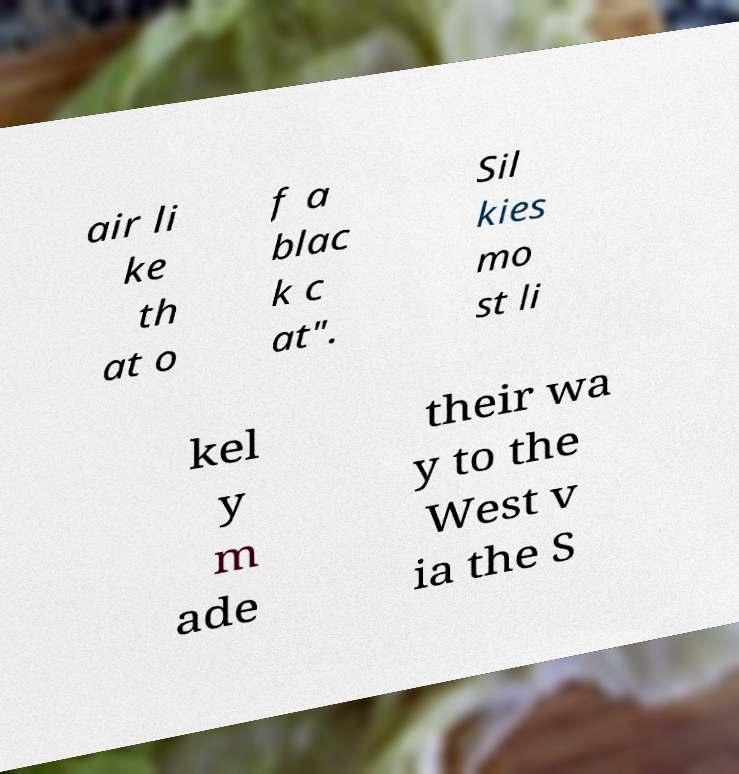Please read and relay the text visible in this image. What does it say? air li ke th at o f a blac k c at". Sil kies mo st li kel y m ade their wa y to the West v ia the S 